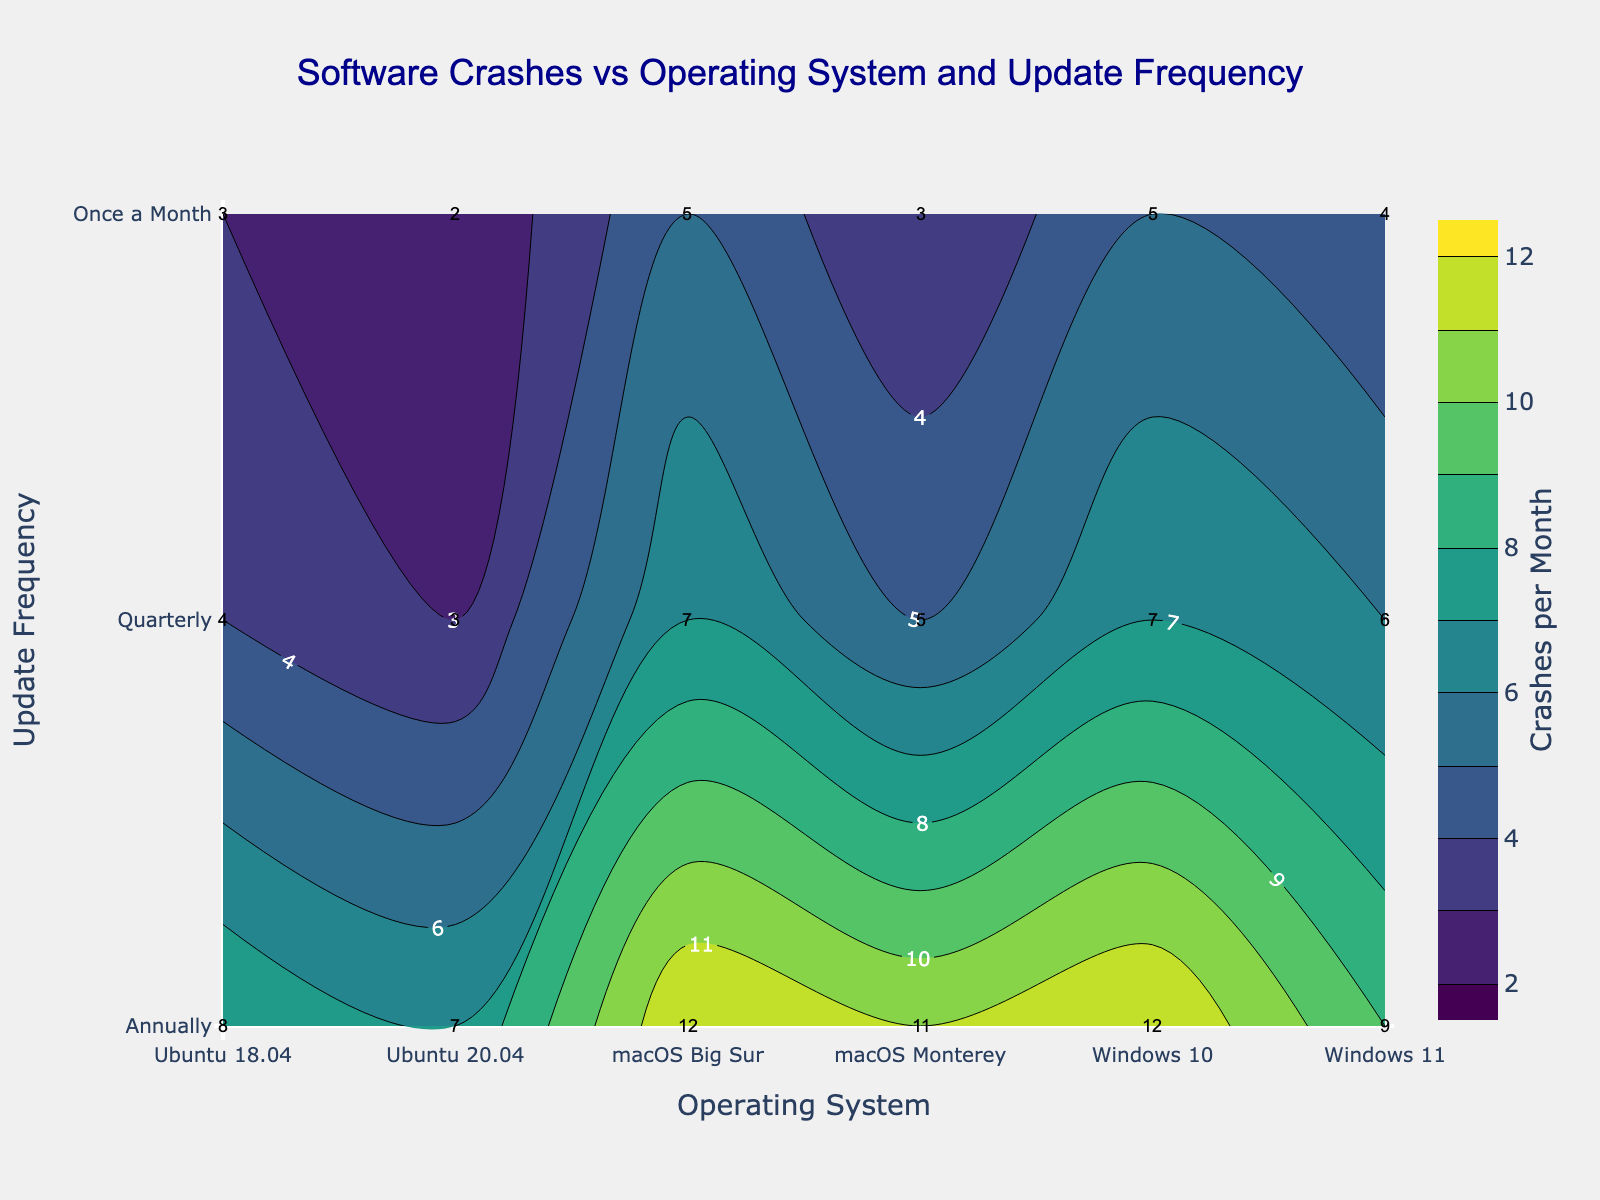What's the title of the figure? The title of the figure is displayed prominently at the top of the plot, showing a larger font size and differing color.
Answer: Software Crashes vs Operating System and Update Frequency What is the highest number of software crashes per month shown on the plot? The contour plot uses color gradients to indicate different levels of crashes, and the highest contour label or the color bar end value represents the maximum crashes per month.
Answer: 12 How often is Ubuntu 20.04 updated when it experiences 7 crashes per month? By locating the point for Ubuntu 20.04 on the x-axis, check the corresponding update frequency (y-axis) that intersects with the contour labeled '7'.
Answer: Annually Which operating system has fewer crashes when updated quarterly, macOS Monterey or macOS Big Sur? Identify the contour values corresponding to 'Quarterly' for both operating systems and compare the numbers.
Answer: macOS Monterey On average, how many crashes per month do Windows 10 experience with updates done quarterly and annually? Find the contour values for Windows 10 updated quarterly and annually, then calculate their average: (7+12)/2.
Answer: 9.5 Which operating system exhibits the fewest crashes per month when updated once a month? Look for the lowest contour value along the 'Once a Month' update frequency and identify the operating system associated with that value.
Answer: Ubuntu 20.04 Compare the number of monthly crashes for macOS Big Sur and Windows 11 when both are updated annually. Which one has fewer crashes? Check the contour values for both operating systems under "Annually" and compare the numbers.
Answer: Windows 11 Is there any operating system that experiences fewer than 5 crashes per month when updated quarterly? Examine the contour plot for any values less than 5 along the "Quarterly" update frequency for all operating systems.
Answer: Yes When updated once a month, how many more crashes does macOS Big Sur experience compared to macOS Monterey? Find the contour values for both macOS Big Sur and macOS Monterey under "Once a Month", then calculate the difference: 5 - 3.
Answer: 2 Which update frequency tends to have the highest number of crashes across all operating systems? Identify the update frequency associated with the highest contour values across all operating systems.
Answer: Annually 